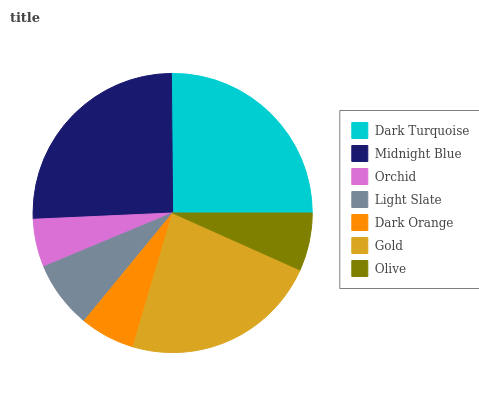Is Orchid the minimum?
Answer yes or no. Yes. Is Midnight Blue the maximum?
Answer yes or no. Yes. Is Midnight Blue the minimum?
Answer yes or no. No. Is Orchid the maximum?
Answer yes or no. No. Is Midnight Blue greater than Orchid?
Answer yes or no. Yes. Is Orchid less than Midnight Blue?
Answer yes or no. Yes. Is Orchid greater than Midnight Blue?
Answer yes or no. No. Is Midnight Blue less than Orchid?
Answer yes or no. No. Is Light Slate the high median?
Answer yes or no. Yes. Is Light Slate the low median?
Answer yes or no. Yes. Is Dark Turquoise the high median?
Answer yes or no. No. Is Gold the low median?
Answer yes or no. No. 